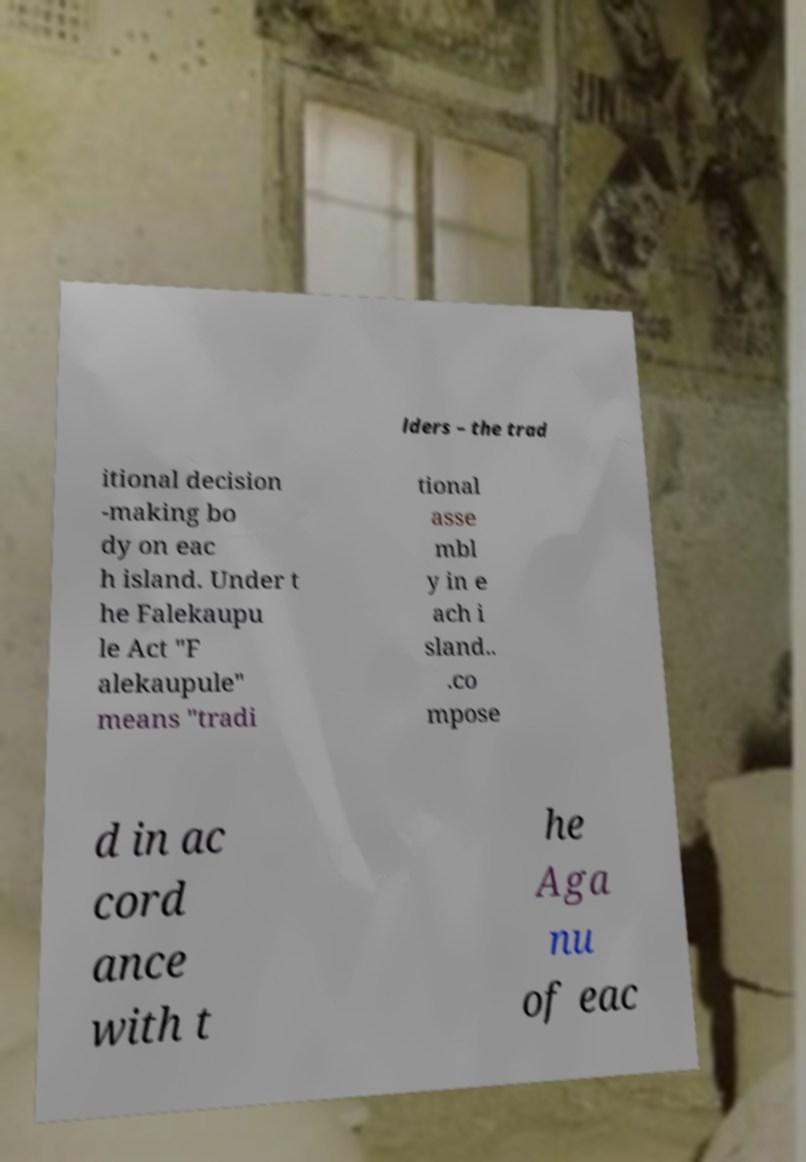Could you extract and type out the text from this image? lders – the trad itional decision -making bo dy on eac h island. Under t he Falekaupu le Act "F alekaupule" means "tradi tional asse mbl y in e ach i sland.. .co mpose d in ac cord ance with t he Aga nu of eac 